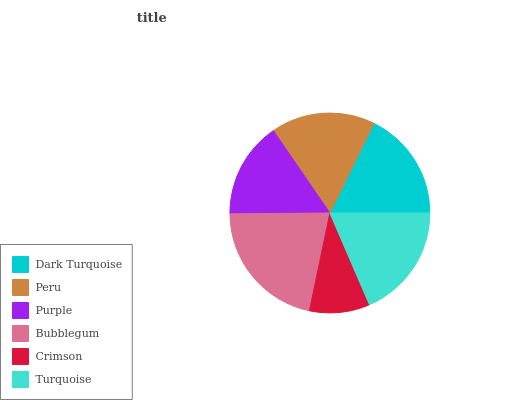Is Crimson the minimum?
Answer yes or no. Yes. Is Bubblegum the maximum?
Answer yes or no. Yes. Is Peru the minimum?
Answer yes or no. No. Is Peru the maximum?
Answer yes or no. No. Is Dark Turquoise greater than Peru?
Answer yes or no. Yes. Is Peru less than Dark Turquoise?
Answer yes or no. Yes. Is Peru greater than Dark Turquoise?
Answer yes or no. No. Is Dark Turquoise less than Peru?
Answer yes or no. No. Is Dark Turquoise the high median?
Answer yes or no. Yes. Is Peru the low median?
Answer yes or no. Yes. Is Turquoise the high median?
Answer yes or no. No. Is Turquoise the low median?
Answer yes or no. No. 